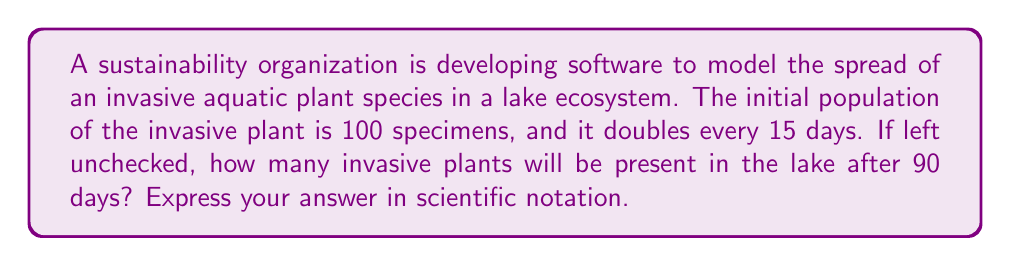Show me your answer to this math problem. To solve this problem, we need to use the exponential growth formula:

$$ A = A_0 \cdot 2^n $$

Where:
$A$ = final amount
$A_0$ = initial amount
$n$ = number of doubling periods

1. First, let's determine the number of doubling periods in 90 days:
   $$ n = \frac{90 \text{ days}}{15 \text{ days per doubling}} = 6 \text{ doubling periods} $$

2. Now, we can plug the values into our formula:
   $$ A = 100 \cdot 2^6 $$

3. Calculate $2^6$:
   $$ 2^6 = 64 $$

4. Multiply by the initial amount:
   $$ A = 100 \cdot 64 = 6400 $$

5. Express the result in scientific notation:
   $$ A = 6.4 \times 10^3 $$

This exponential growth model demonstrates the rapid spread of invasive species in ecosystems, highlighting the importance of early detection and intervention in environmental monitoring.
Answer: $6.4 \times 10^3$ invasive plants 